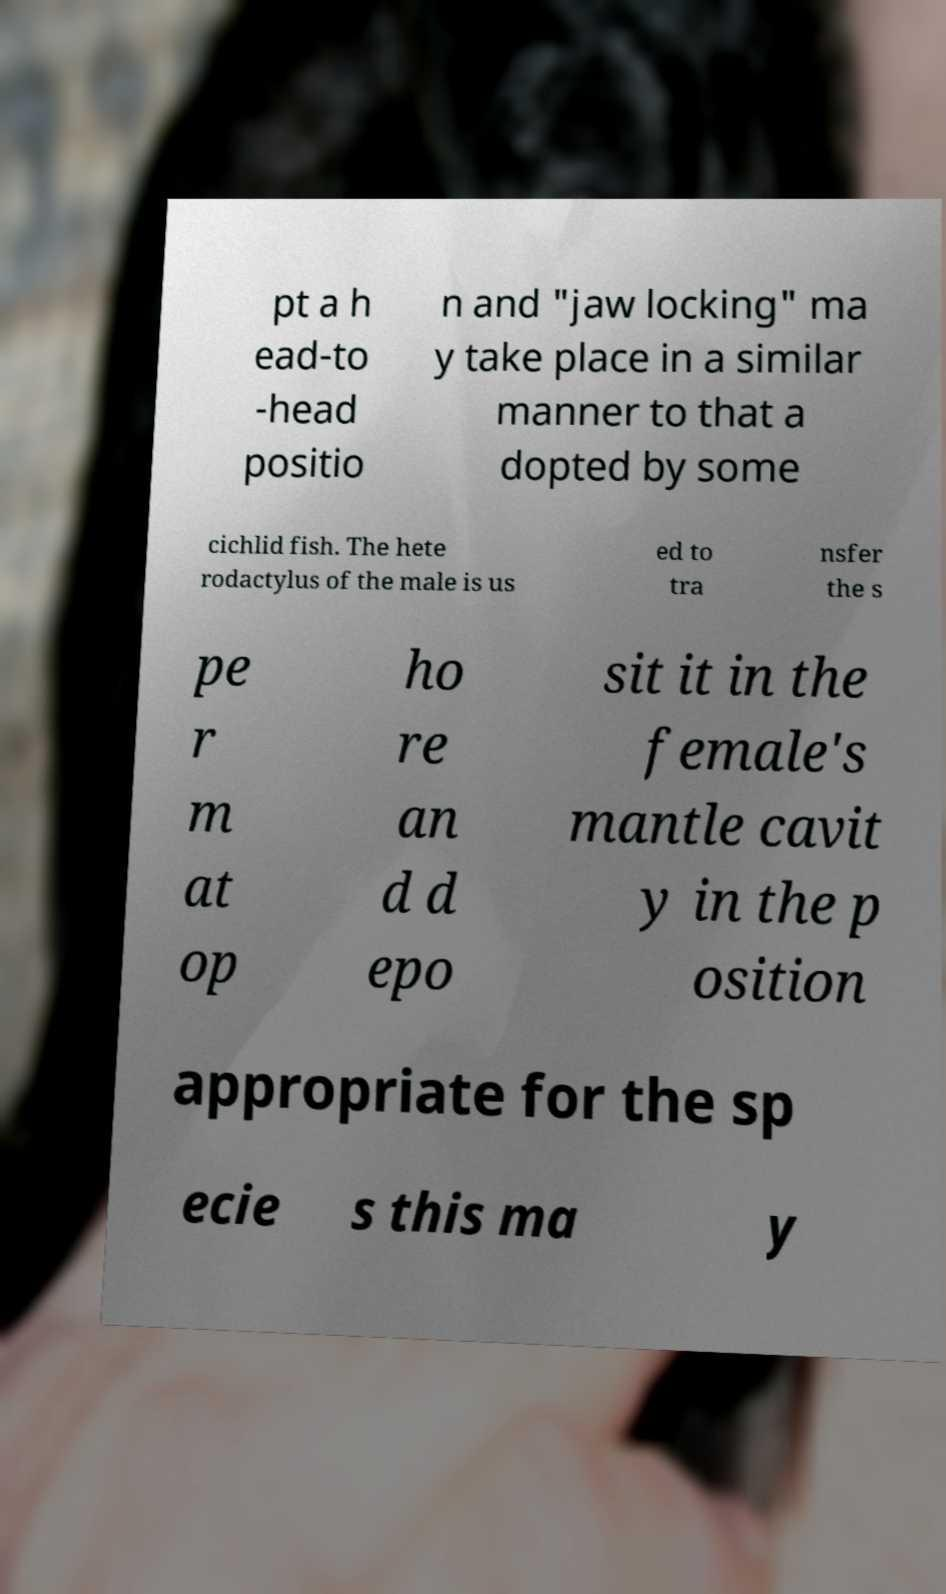Could you assist in decoding the text presented in this image and type it out clearly? pt a h ead-to -head positio n and "jaw locking" ma y take place in a similar manner to that a dopted by some cichlid fish. The hete rodactylus of the male is us ed to tra nsfer the s pe r m at op ho re an d d epo sit it in the female's mantle cavit y in the p osition appropriate for the sp ecie s this ma y 